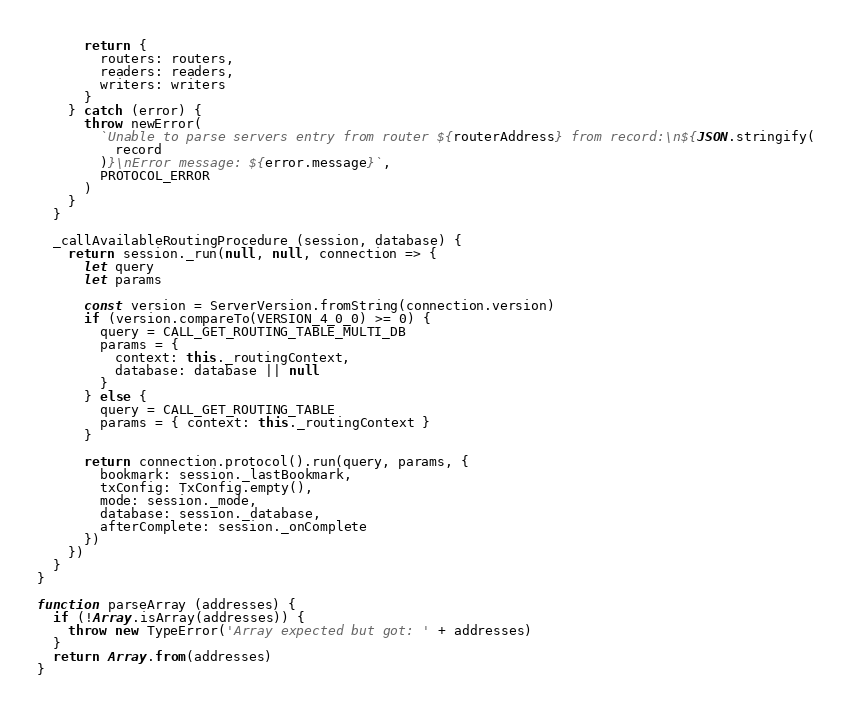<code> <loc_0><loc_0><loc_500><loc_500><_JavaScript_>
      return {
        routers: routers,
        readers: readers,
        writers: writers
      }
    } catch (error) {
      throw newError(
        `Unable to parse servers entry from router ${routerAddress} from record:\n${JSON.stringify(
          record
        )}\nError message: ${error.message}`,
        PROTOCOL_ERROR
      )
    }
  }

  _callAvailableRoutingProcedure (session, database) {
    return session._run(null, null, connection => {
      let query
      let params

      const version = ServerVersion.fromString(connection.version)
      if (version.compareTo(VERSION_4_0_0) >= 0) {
        query = CALL_GET_ROUTING_TABLE_MULTI_DB
        params = {
          context: this._routingContext,
          database: database || null
        }
      } else {
        query = CALL_GET_ROUTING_TABLE
        params = { context: this._routingContext }
      }

      return connection.protocol().run(query, params, {
        bookmark: session._lastBookmark,
        txConfig: TxConfig.empty(),
        mode: session._mode,
        database: session._database,
        afterComplete: session._onComplete
      })
    })
  }
}

function parseArray (addresses) {
  if (!Array.isArray(addresses)) {
    throw new TypeError('Array expected but got: ' + addresses)
  }
  return Array.from(addresses)
}
</code> 